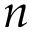<formula> <loc_0><loc_0><loc_500><loc_500>n</formula> 